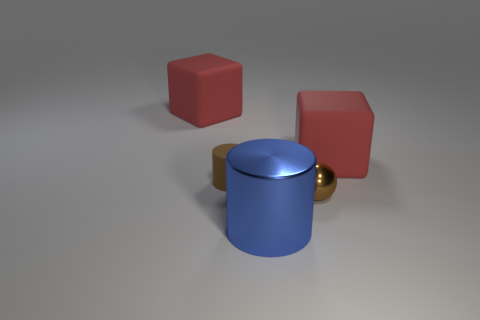There is a big rubber cube that is on the right side of the tiny brown rubber thing; is it the same color as the block that is on the left side of the small brown sphere?
Offer a very short reply. Yes. The large rubber cube on the right side of the cylinder that is in front of the tiny metallic sphere that is in front of the tiny matte cylinder is what color?
Keep it short and to the point. Red. Are there any cylinders behind the large blue metallic object in front of the tiny matte cylinder?
Your answer should be compact. Yes. There is a tiny object that is in front of the small brown matte thing; does it have the same shape as the tiny brown matte object?
Your answer should be compact. No. Is there any other thing that is the same shape as the brown shiny thing?
Offer a very short reply. No. What number of blocks are blue metal things or brown matte objects?
Ensure brevity in your answer.  0. How many tiny brown things are there?
Your response must be concise. 2. What size is the matte thing that is in front of the large red rubber cube that is on the right side of the small cylinder?
Offer a terse response. Small. How many other objects are there of the same size as the matte cylinder?
Offer a very short reply. 1. There is a large shiny cylinder; what number of metallic things are behind it?
Offer a very short reply. 1. 